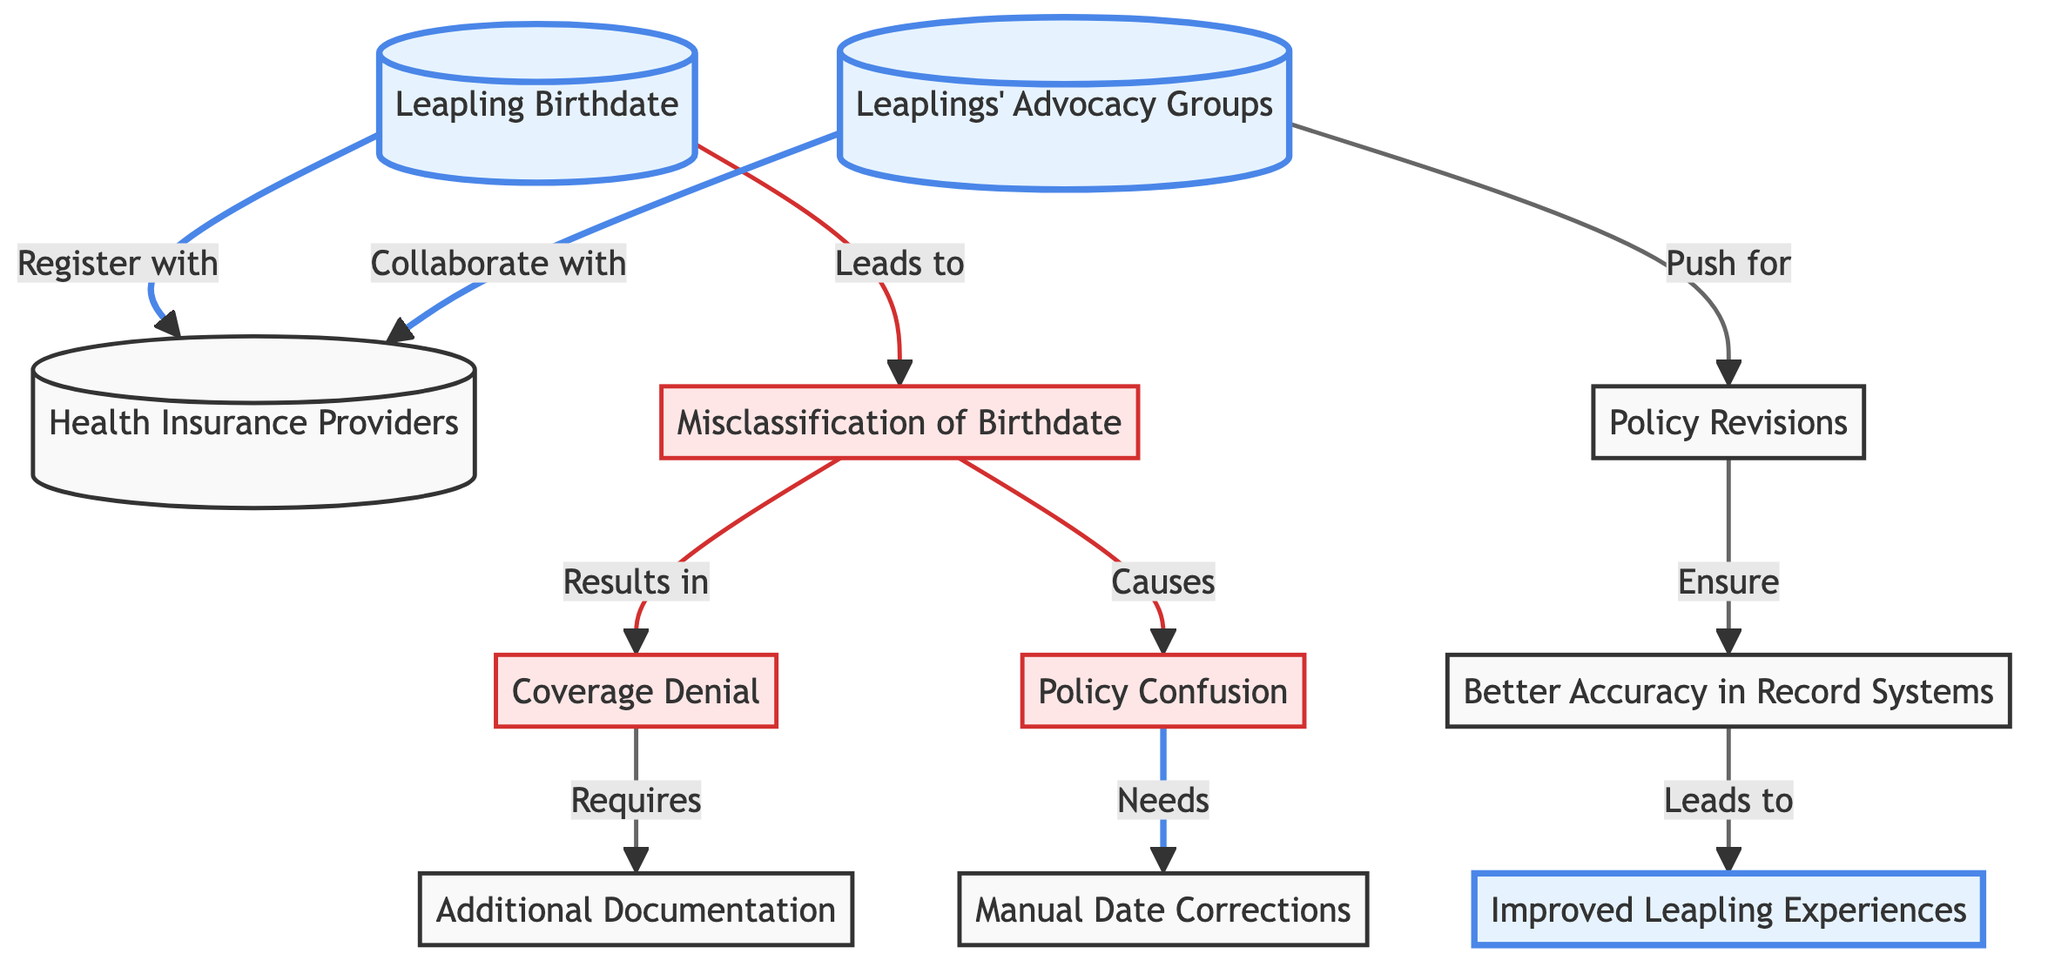What is the starting point of the flowchart? The starting point of the flowchart is the node labeled "Leapling Birthdate."
Answer: Leapling Birthdate How many issues are identified in the diagram? There are three issues identified in the diagram: "Misclassification of Birthdate," "Coverage Denial," and "Policy Confusion."
Answer: 3 What does "Coverage Denial" require according to the flowchart? According to the flowchart, "Coverage Denial" requires "Additional Documentation."
Answer: Additional Documentation Which node collaborates with Health Insurance Providers? The node that collaborates with Health Insurance Providers is "Leaplings' Advocacy Groups."
Answer: Leaplings' Advocacy Groups What leads to improved experiences for leaplings? Improved experiences for leaplings are achieved after "Better Accuracy in Record Systems."
Answer: Better Accuracy in Record Systems What results from misclassification of birthdate? Misclassification of birthdate results in "Coverage Denial."
Answer: Coverage Denial What action do leaplings' advocacy groups push for? Leaplings' advocacy groups push for "Policy Revisions."
Answer: Policy Revisions What does the flow from "Policy Revisions" ensure? The flow from "Policy Revisions" ensures "Better Accuracy in Record Systems."
Answer: Better Accuracy in Record Systems What kind of relationship exists between "Leapling Birthdate" and "Health Insurance Providers"? The relationship is that "Leapling Birthdate" leads to registering with "Health Insurance Providers."
Answer: Leads to 